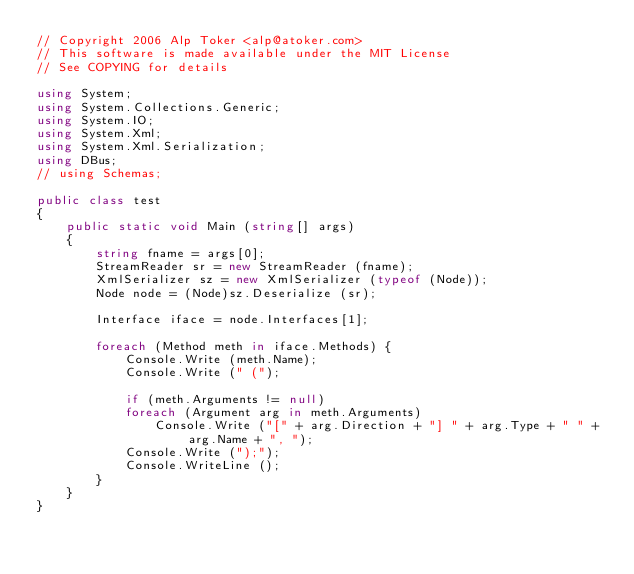Convert code to text. <code><loc_0><loc_0><loc_500><loc_500><_C#_>// Copyright 2006 Alp Toker <alp@atoker.com>
// This software is made available under the MIT License
// See COPYING for details

using System;
using System.Collections.Generic;
using System.IO;
using System.Xml;
using System.Xml.Serialization;
using DBus;
// using Schemas;

public class test
{
	public static void Main (string[] args)
	{
		string fname = args[0];
		StreamReader sr = new StreamReader (fname);
		XmlSerializer sz = new XmlSerializer (typeof (Node));
		Node node = (Node)sz.Deserialize (sr);

		Interface iface = node.Interfaces[1];

		foreach (Method meth in iface.Methods) {
			Console.Write (meth.Name);
			Console.Write (" (");

			if (meth.Arguments != null)
			foreach (Argument arg in meth.Arguments)
				Console.Write ("[" + arg.Direction + "] " + arg.Type + " " + arg.Name + ", ");
			Console.Write (");");
			Console.WriteLine ();
		}
	}
}
</code> 